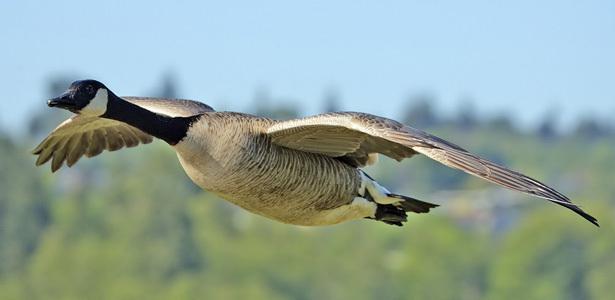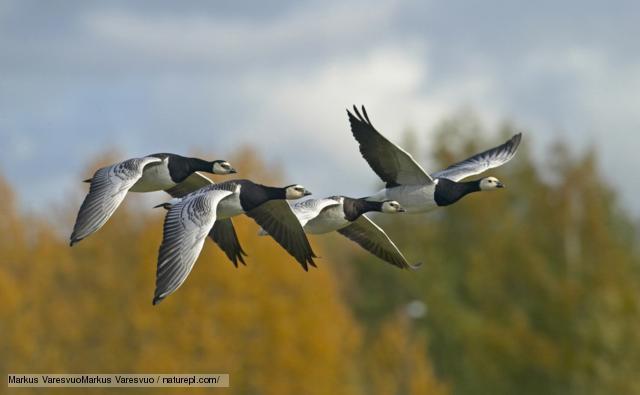The first image is the image on the left, the second image is the image on the right. Considering the images on both sides, is "All images show birds that are flying." valid? Answer yes or no. Yes. 